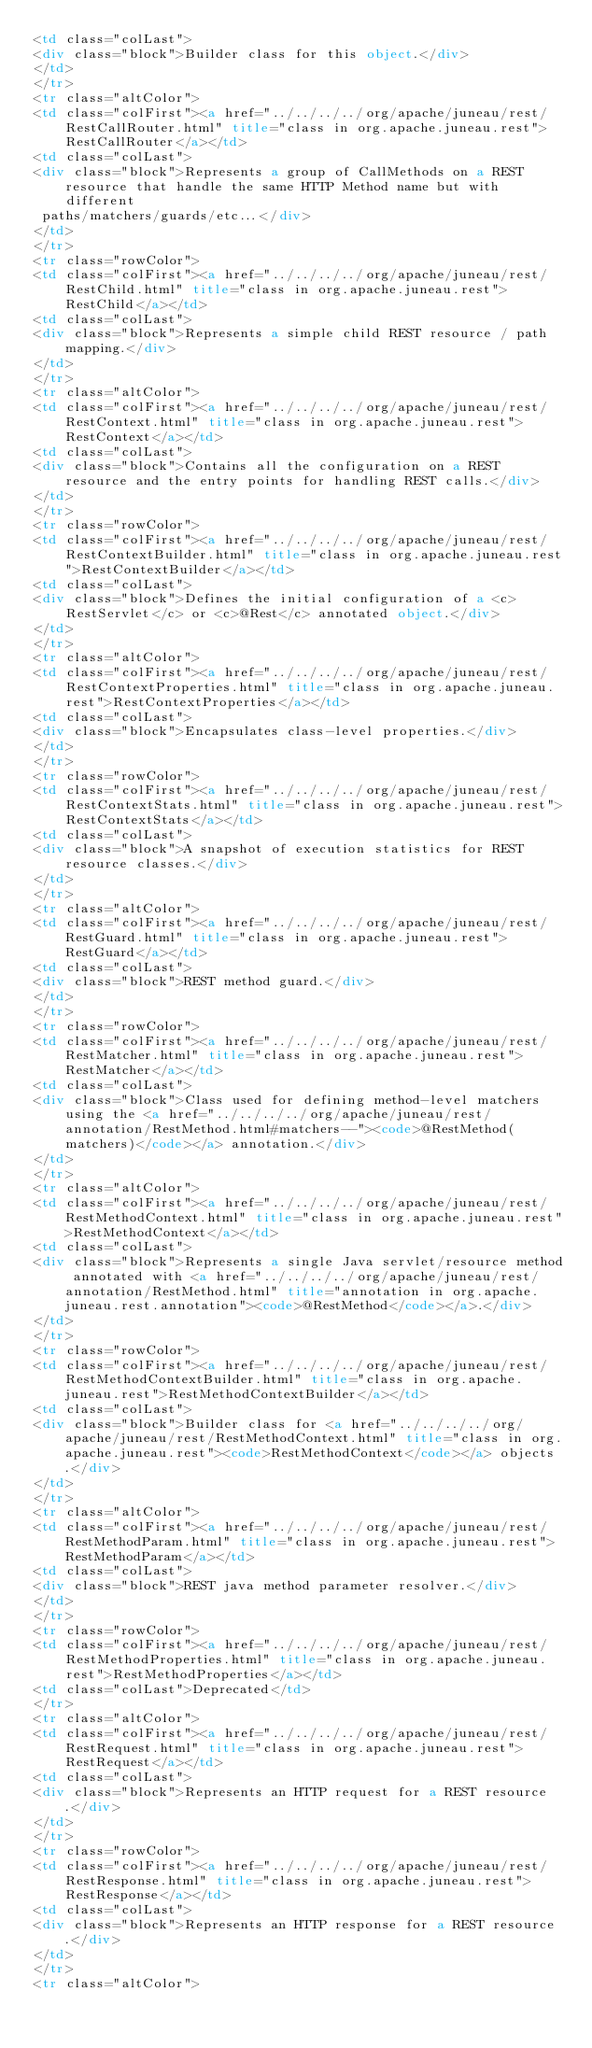Convert code to text. <code><loc_0><loc_0><loc_500><loc_500><_HTML_><td class="colLast">
<div class="block">Builder class for this object.</div>
</td>
</tr>
<tr class="altColor">
<td class="colFirst"><a href="../../../../org/apache/juneau/rest/RestCallRouter.html" title="class in org.apache.juneau.rest">RestCallRouter</a></td>
<td class="colLast">
<div class="block">Represents a group of CallMethods on a REST resource that handle the same HTTP Method name but with different
 paths/matchers/guards/etc...</div>
</td>
</tr>
<tr class="rowColor">
<td class="colFirst"><a href="../../../../org/apache/juneau/rest/RestChild.html" title="class in org.apache.juneau.rest">RestChild</a></td>
<td class="colLast">
<div class="block">Represents a simple child REST resource / path mapping.</div>
</td>
</tr>
<tr class="altColor">
<td class="colFirst"><a href="../../../../org/apache/juneau/rest/RestContext.html" title="class in org.apache.juneau.rest">RestContext</a></td>
<td class="colLast">
<div class="block">Contains all the configuration on a REST resource and the entry points for handling REST calls.</div>
</td>
</tr>
<tr class="rowColor">
<td class="colFirst"><a href="../../../../org/apache/juneau/rest/RestContextBuilder.html" title="class in org.apache.juneau.rest">RestContextBuilder</a></td>
<td class="colLast">
<div class="block">Defines the initial configuration of a <c>RestServlet</c> or <c>@Rest</c> annotated object.</div>
</td>
</tr>
<tr class="altColor">
<td class="colFirst"><a href="../../../../org/apache/juneau/rest/RestContextProperties.html" title="class in org.apache.juneau.rest">RestContextProperties</a></td>
<td class="colLast">
<div class="block">Encapsulates class-level properties.</div>
</td>
</tr>
<tr class="rowColor">
<td class="colFirst"><a href="../../../../org/apache/juneau/rest/RestContextStats.html" title="class in org.apache.juneau.rest">RestContextStats</a></td>
<td class="colLast">
<div class="block">A snapshot of execution statistics for REST resource classes.</div>
</td>
</tr>
<tr class="altColor">
<td class="colFirst"><a href="../../../../org/apache/juneau/rest/RestGuard.html" title="class in org.apache.juneau.rest">RestGuard</a></td>
<td class="colLast">
<div class="block">REST method guard.</div>
</td>
</tr>
<tr class="rowColor">
<td class="colFirst"><a href="../../../../org/apache/juneau/rest/RestMatcher.html" title="class in org.apache.juneau.rest">RestMatcher</a></td>
<td class="colLast">
<div class="block">Class used for defining method-level matchers using the <a href="../../../../org/apache/juneau/rest/annotation/RestMethod.html#matchers--"><code>@RestMethod(matchers)</code></a> annotation.</div>
</td>
</tr>
<tr class="altColor">
<td class="colFirst"><a href="../../../../org/apache/juneau/rest/RestMethodContext.html" title="class in org.apache.juneau.rest">RestMethodContext</a></td>
<td class="colLast">
<div class="block">Represents a single Java servlet/resource method annotated with <a href="../../../../org/apache/juneau/rest/annotation/RestMethod.html" title="annotation in org.apache.juneau.rest.annotation"><code>@RestMethod</code></a>.</div>
</td>
</tr>
<tr class="rowColor">
<td class="colFirst"><a href="../../../../org/apache/juneau/rest/RestMethodContextBuilder.html" title="class in org.apache.juneau.rest">RestMethodContextBuilder</a></td>
<td class="colLast">
<div class="block">Builder class for <a href="../../../../org/apache/juneau/rest/RestMethodContext.html" title="class in org.apache.juneau.rest"><code>RestMethodContext</code></a> objects.</div>
</td>
</tr>
<tr class="altColor">
<td class="colFirst"><a href="../../../../org/apache/juneau/rest/RestMethodParam.html" title="class in org.apache.juneau.rest">RestMethodParam</a></td>
<td class="colLast">
<div class="block">REST java method parameter resolver.</div>
</td>
</tr>
<tr class="rowColor">
<td class="colFirst"><a href="../../../../org/apache/juneau/rest/RestMethodProperties.html" title="class in org.apache.juneau.rest">RestMethodProperties</a></td>
<td class="colLast">Deprecated</td>
</tr>
<tr class="altColor">
<td class="colFirst"><a href="../../../../org/apache/juneau/rest/RestRequest.html" title="class in org.apache.juneau.rest">RestRequest</a></td>
<td class="colLast">
<div class="block">Represents an HTTP request for a REST resource.</div>
</td>
</tr>
<tr class="rowColor">
<td class="colFirst"><a href="../../../../org/apache/juneau/rest/RestResponse.html" title="class in org.apache.juneau.rest">RestResponse</a></td>
<td class="colLast">
<div class="block">Represents an HTTP response for a REST resource.</div>
</td>
</tr>
<tr class="altColor"></code> 